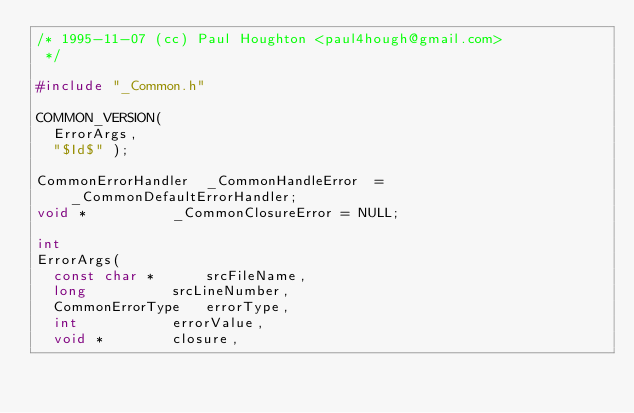Convert code to text. <code><loc_0><loc_0><loc_500><loc_500><_C_>/* 1995-11-07 (cc) Paul Houghton <paul4hough@gmail.com>
 */

#include "_Common.h"

COMMON_VERSION(
  ErrorArgs,
  "$Id$" );

CommonErrorHandler	_CommonHandleError  = _CommonDefaultErrorHandler;
void *			_CommonClosureError = NULL;

int
ErrorArgs(
  const char *	    srcFileName,
  long		    srcLineNumber,
  CommonErrorType   errorType,
  int		    errorValue,
  void *	    closure,</code> 